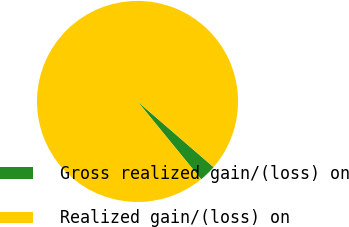Convert chart to OTSL. <chart><loc_0><loc_0><loc_500><loc_500><pie_chart><fcel>Gross realized gain/(loss) on<fcel>Realized gain/(loss) on<nl><fcel>2.75%<fcel>97.25%<nl></chart> 